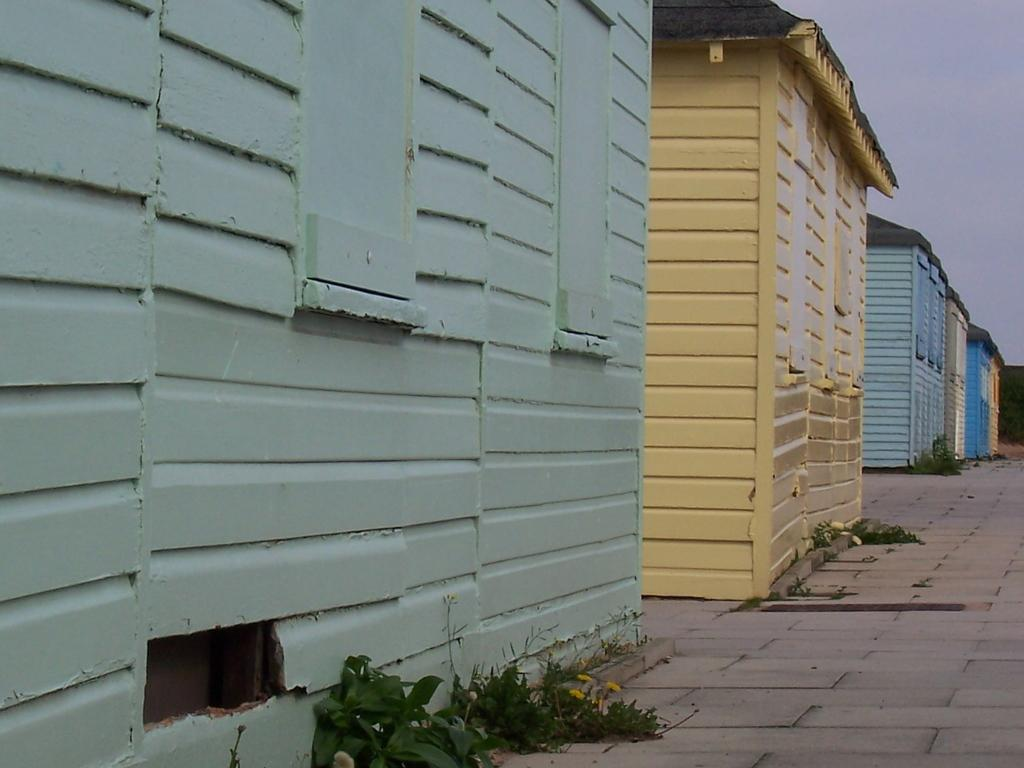What type of houses can be seen in the image? There are wooden houses in the image. What is on the path in front of the houses? There is grass on the path in front of the houses. What can be seen in the background of the image? The sky is visible in the background of the image. What appliance is being used to limit the experience of the wooden houses in the image? There is no appliance present in the image, and the wooden houses are not experiencing any limitations. 